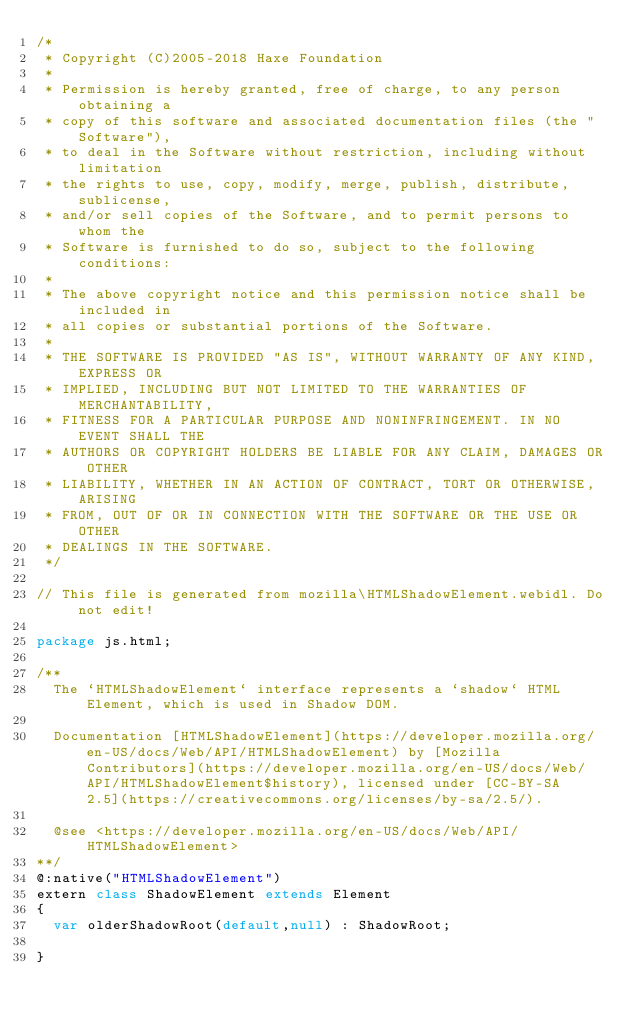Convert code to text. <code><loc_0><loc_0><loc_500><loc_500><_Haxe_>/*
 * Copyright (C)2005-2018 Haxe Foundation
 *
 * Permission is hereby granted, free of charge, to any person obtaining a
 * copy of this software and associated documentation files (the "Software"),
 * to deal in the Software without restriction, including without limitation
 * the rights to use, copy, modify, merge, publish, distribute, sublicense,
 * and/or sell copies of the Software, and to permit persons to whom the
 * Software is furnished to do so, subject to the following conditions:
 *
 * The above copyright notice and this permission notice shall be included in
 * all copies or substantial portions of the Software.
 *
 * THE SOFTWARE IS PROVIDED "AS IS", WITHOUT WARRANTY OF ANY KIND, EXPRESS OR
 * IMPLIED, INCLUDING BUT NOT LIMITED TO THE WARRANTIES OF MERCHANTABILITY,
 * FITNESS FOR A PARTICULAR PURPOSE AND NONINFRINGEMENT. IN NO EVENT SHALL THE
 * AUTHORS OR COPYRIGHT HOLDERS BE LIABLE FOR ANY CLAIM, DAMAGES OR OTHER
 * LIABILITY, WHETHER IN AN ACTION OF CONTRACT, TORT OR OTHERWISE, ARISING
 * FROM, OUT OF OR IN CONNECTION WITH THE SOFTWARE OR THE USE OR OTHER
 * DEALINGS IN THE SOFTWARE.
 */

// This file is generated from mozilla\HTMLShadowElement.webidl. Do not edit!

package js.html;

/**
	The `HTMLShadowElement` interface represents a `shadow` HTML Element, which is used in Shadow DOM.

	Documentation [HTMLShadowElement](https://developer.mozilla.org/en-US/docs/Web/API/HTMLShadowElement) by [Mozilla Contributors](https://developer.mozilla.org/en-US/docs/Web/API/HTMLShadowElement$history), licensed under [CC-BY-SA 2.5](https://creativecommons.org/licenses/by-sa/2.5/).

	@see <https://developer.mozilla.org/en-US/docs/Web/API/HTMLShadowElement>
**/
@:native("HTMLShadowElement")
extern class ShadowElement extends Element
{
	var olderShadowRoot(default,null) : ShadowRoot;
	
}</code> 